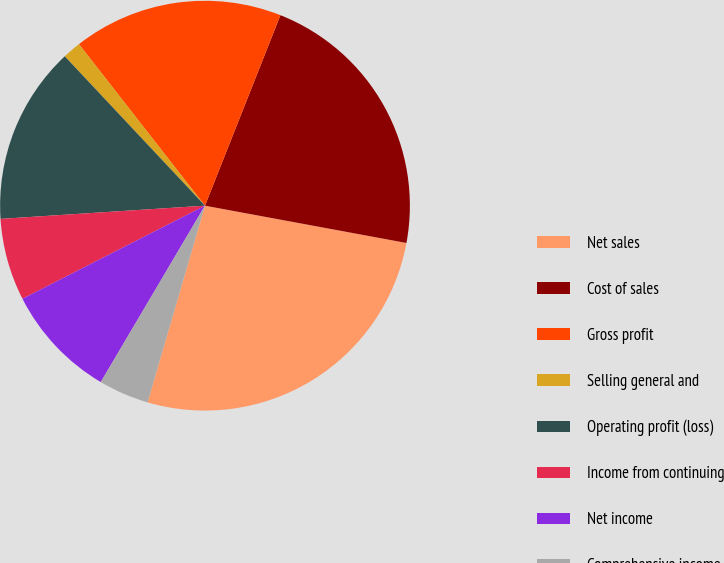<chart> <loc_0><loc_0><loc_500><loc_500><pie_chart><fcel>Net sales<fcel>Cost of sales<fcel>Gross profit<fcel>Selling general and<fcel>Operating profit (loss)<fcel>Income from continuing<fcel>Net income<fcel>Comprehensive income<nl><fcel>26.61%<fcel>21.91%<fcel>16.55%<fcel>1.45%<fcel>14.03%<fcel>6.48%<fcel>9.0%<fcel>3.97%<nl></chart> 